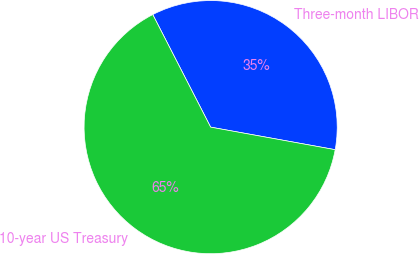<chart> <loc_0><loc_0><loc_500><loc_500><pie_chart><fcel>Three-month LIBOR<fcel>10-year US Treasury<nl><fcel>35.41%<fcel>64.59%<nl></chart> 